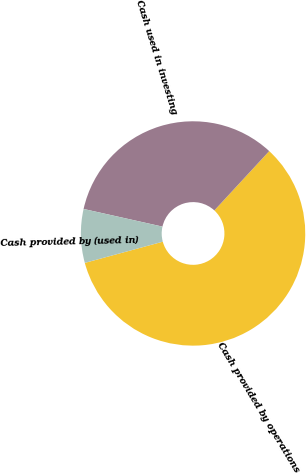Convert chart to OTSL. <chart><loc_0><loc_0><loc_500><loc_500><pie_chart><fcel>Cash provided by operations<fcel>Cash used in investing<fcel>Cash provided by (used in)<nl><fcel>58.9%<fcel>33.37%<fcel>7.73%<nl></chart> 